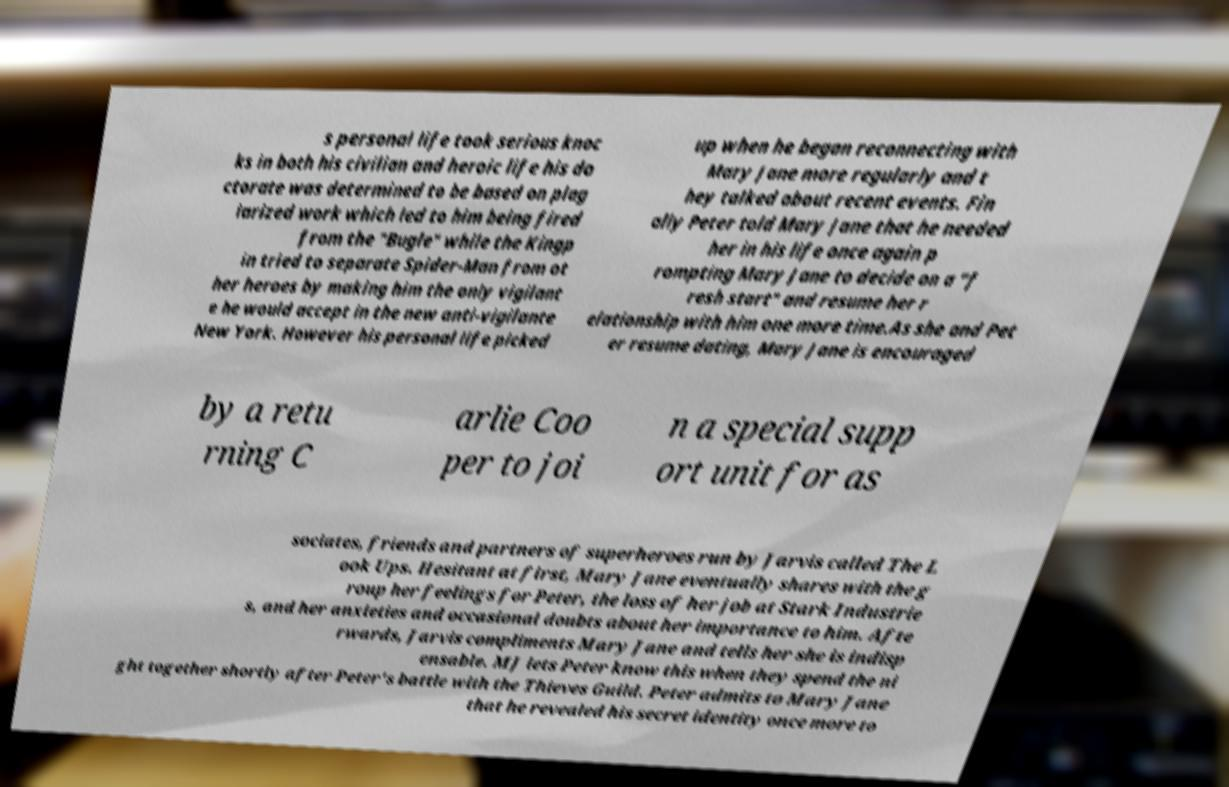Please read and relay the text visible in this image. What does it say? s personal life took serious knoc ks in both his civilian and heroic life his do ctorate was determined to be based on plag iarized work which led to him being fired from the "Bugle" while the Kingp in tried to separate Spider-Man from ot her heroes by making him the only vigilant e he would accept in the new anti-vigilante New York. However his personal life picked up when he began reconnecting with Mary Jane more regularly and t hey talked about recent events. Fin ally Peter told Mary Jane that he needed her in his life once again p rompting Mary Jane to decide on a "f resh start" and resume her r elationship with him one more time.As she and Pet er resume dating, Mary Jane is encouraged by a retu rning C arlie Coo per to joi n a special supp ort unit for as sociates, friends and partners of superheroes run by Jarvis called The L ook Ups. Hesitant at first, Mary Jane eventually shares with the g roup her feelings for Peter, the loss of her job at Stark Industrie s, and her anxieties and occasional doubts about her importance to him. Afte rwards, Jarvis compliments Mary Jane and tells her she is indisp ensable. MJ lets Peter know this when they spend the ni ght together shortly after Peter's battle with the Thieves Guild. Peter admits to Mary Jane that he revealed his secret identity once more to 